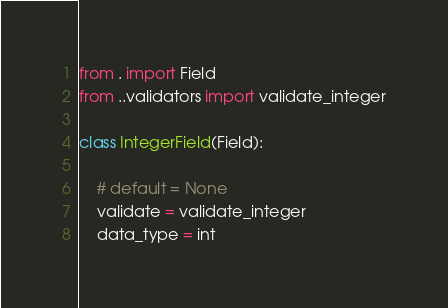<code> <loc_0><loc_0><loc_500><loc_500><_Python_>from . import Field
from ..validators import validate_integer

class IntegerField(Field):

    # default = None
    validate = validate_integer
    data_type = int</code> 